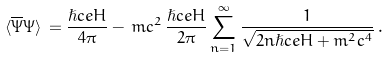Convert formula to latex. <formula><loc_0><loc_0><loc_500><loc_500>\langle \overline { \Psi } \Psi \rangle \, = \frac { \hslash c e H } { 4 \pi } - \, m c ^ { 2 } \, \frac { \hslash c e H } { 2 \pi } \sum _ { n = 1 } ^ { \infty } \frac { 1 } { \sqrt { 2 n \hslash c e H + m ^ { 2 } c ^ { 4 } } } \, .</formula> 